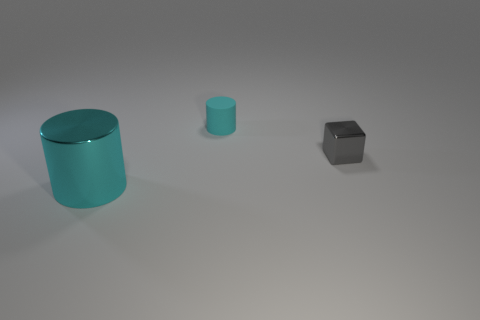Are there any small cyan matte cylinders on the right side of the cyan thing that is in front of the metal cube?
Offer a very short reply. Yes. Is the color of the metal object that is on the left side of the tiny shiny cube the same as the metal thing behind the metallic cylinder?
Offer a terse response. No. What number of cyan objects are in front of the big cyan shiny cylinder?
Offer a terse response. 0. How many other small shiny cubes have the same color as the metal block?
Provide a succinct answer. 0. Are the object that is in front of the tiny gray cube and the small cyan cylinder made of the same material?
Ensure brevity in your answer.  No. What number of things have the same material as the small cyan cylinder?
Ensure brevity in your answer.  0. Are there more tiny rubber objects that are behind the large cyan metal cylinder than big purple balls?
Your response must be concise. Yes. The other thing that is the same color as the large shiny thing is what size?
Ensure brevity in your answer.  Small. Are there any yellow metallic objects of the same shape as the cyan matte thing?
Make the answer very short. No. What number of objects are gray metallic spheres or gray shiny blocks?
Your answer should be compact. 1. 